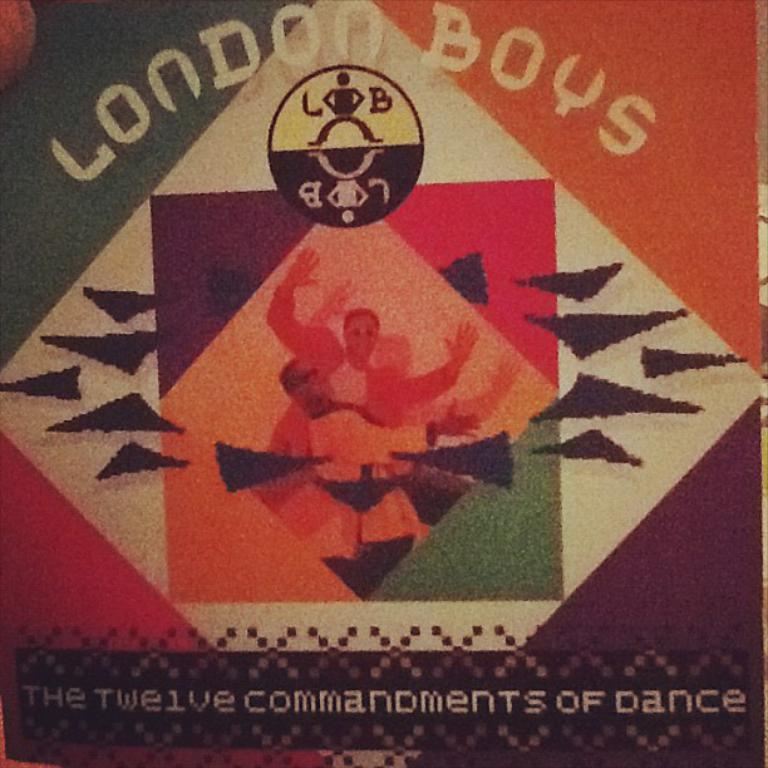<image>
Give a short and clear explanation of the subsequent image. London Boys cover that advertises the twelve commandments of dance. 